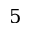<formula> <loc_0><loc_0><loc_500><loc_500>5</formula> 